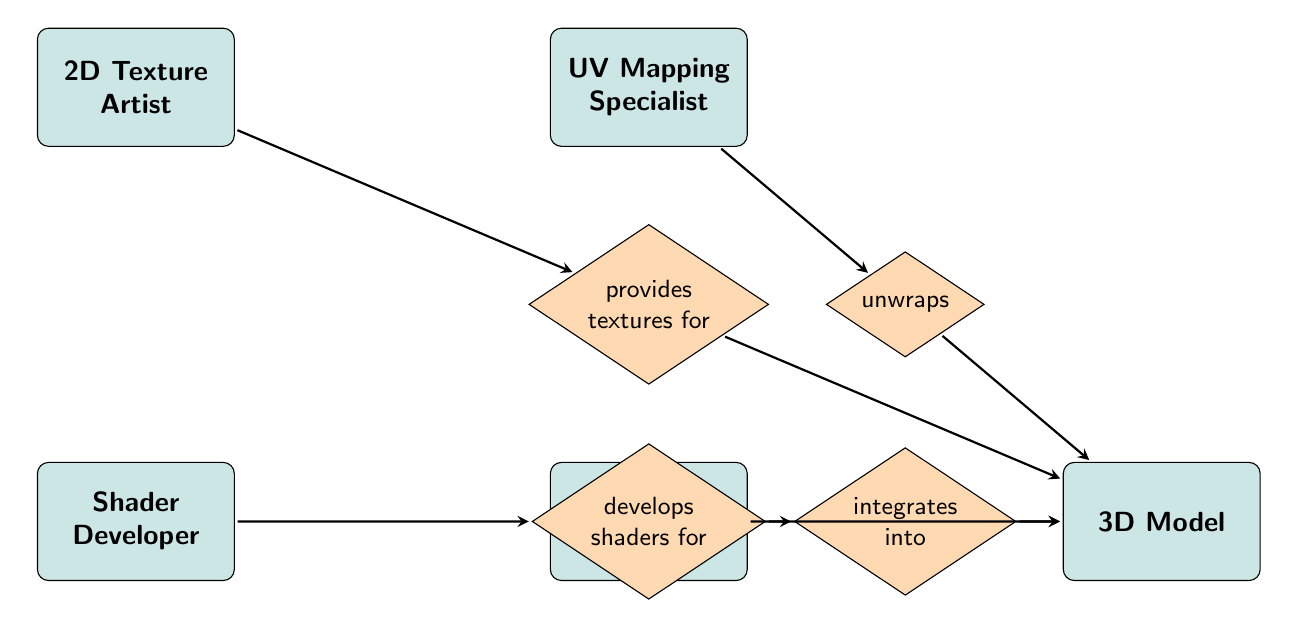What is the total number of entities in the diagram? The diagram lists five distinct entities: 2D Texture Artist, UV Mapping Specialist, Shader Developer, 3D Modeler, and 3D Model. Counting these gives a total of 5 entities.
Answer: 5 Which entity provides textures for the 3D Model? The 2D Texture Artist is directly connected to the 3D Model through the relationship labeled "provides textures for." This indicates that this entity is responsible for supplying textures.
Answer: 2D Texture Artist How many relationships connect to the 3D Model? There are four relationships leading into the 3D Model: "provides textures for," "unwraps," "develops shaders for," and "integrates into." Counting these relationships gives a total of 4.
Answer: 4 Who unwraps the 3D Models? The UV Mapping Specialist is connected to the 3D Model through the relationship labeled "unwraps," indicating that this entity is responsible for unwrapping the models.
Answer: UV Mapping Specialist Which relationship involves Shader Developer and 3D Model? The relationship labeled "develops shaders for" connects the Shader Developer to the 3D Model. This indicates that the Shader Developer is responsible for creating shaders that are applied to the 3D Model.
Answer: develops shaders for What is the purpose of the 3D Modeler in the context of the diagram? The 3D Modeler integrates various elements into the 3D Model by linking with all the artists and specialists. This is shown by the relationship "integrates into," connecting the 3D Modeler directly to the 3D Model.
Answer: integrates into Which two entities are directly linked through the "provides textures for" relationship? The relationship labeled "provides textures for" connects the 2D Texture Artist to the 3D Model, indicating this specific linkage between these two entities.
Answer: 2D Texture Artist and 3D Model What role does the Shader Developer have concerning material quality? The Shader Developer is responsible for ensuring material quality as indicated by their attributes. This highlights their involvement in maintaining the visual integrity of shaders used in the 3D Model.
Answer: ensures material quality 